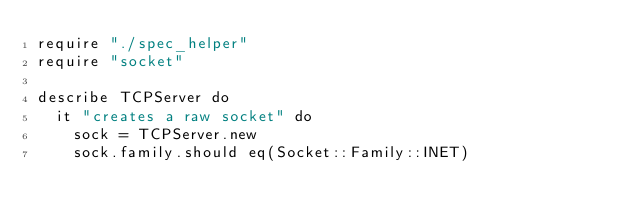Convert code to text. <code><loc_0><loc_0><loc_500><loc_500><_Crystal_>require "./spec_helper"
require "socket"

describe TCPServer do
  it "creates a raw socket" do
    sock = TCPServer.new
    sock.family.should eq(Socket::Family::INET)
</code> 